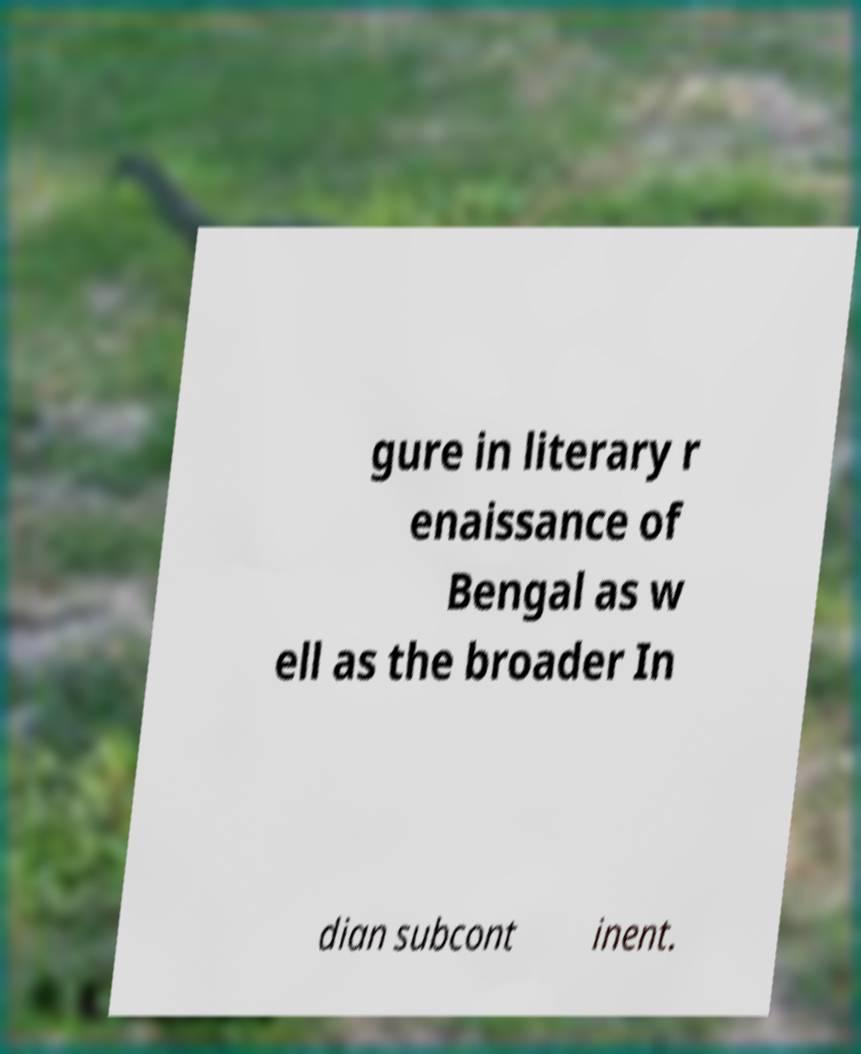There's text embedded in this image that I need extracted. Can you transcribe it verbatim? gure in literary r enaissance of Bengal as w ell as the broader In dian subcont inent. 